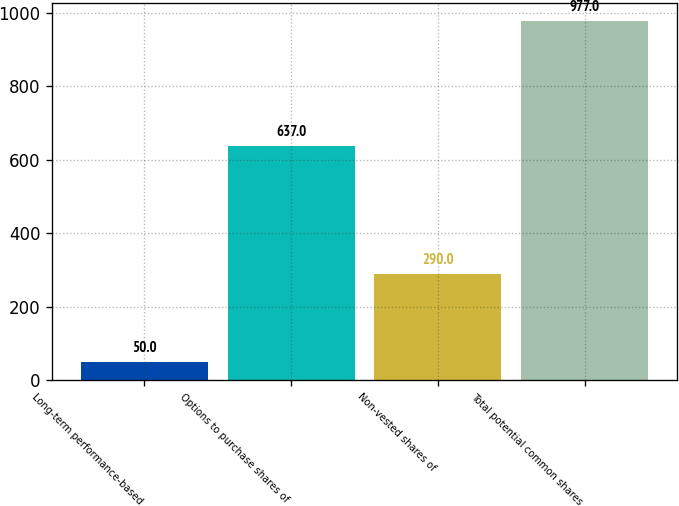Convert chart. <chart><loc_0><loc_0><loc_500><loc_500><bar_chart><fcel>Long-term performance-based<fcel>Options to purchase shares of<fcel>Non-vested shares of<fcel>Total potential common shares<nl><fcel>50<fcel>637<fcel>290<fcel>977<nl></chart> 